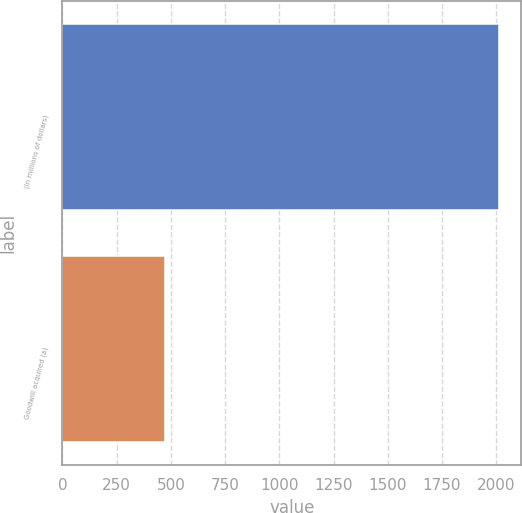Convert chart. <chart><loc_0><loc_0><loc_500><loc_500><bar_chart><fcel>(In millions of dollars)<fcel>Goodwill acquired (a)<nl><fcel>2014<fcel>472<nl></chart> 